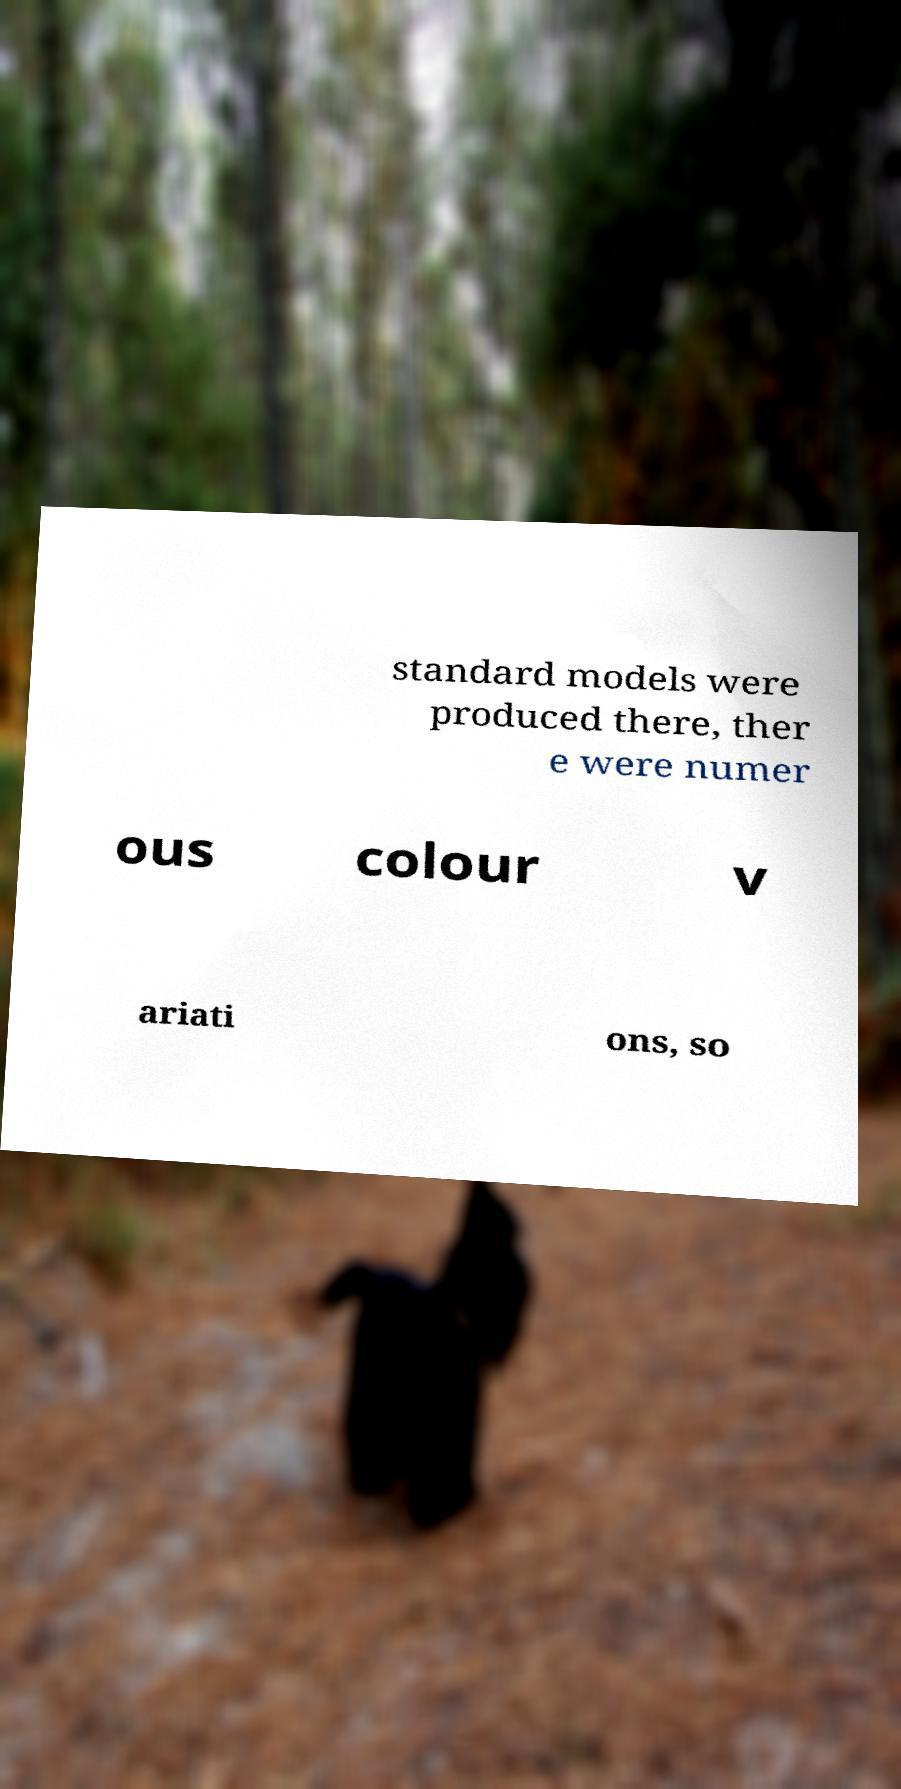Can you read and provide the text displayed in the image?This photo seems to have some interesting text. Can you extract and type it out for me? standard models were produced there, ther e were numer ous colour v ariati ons, so 